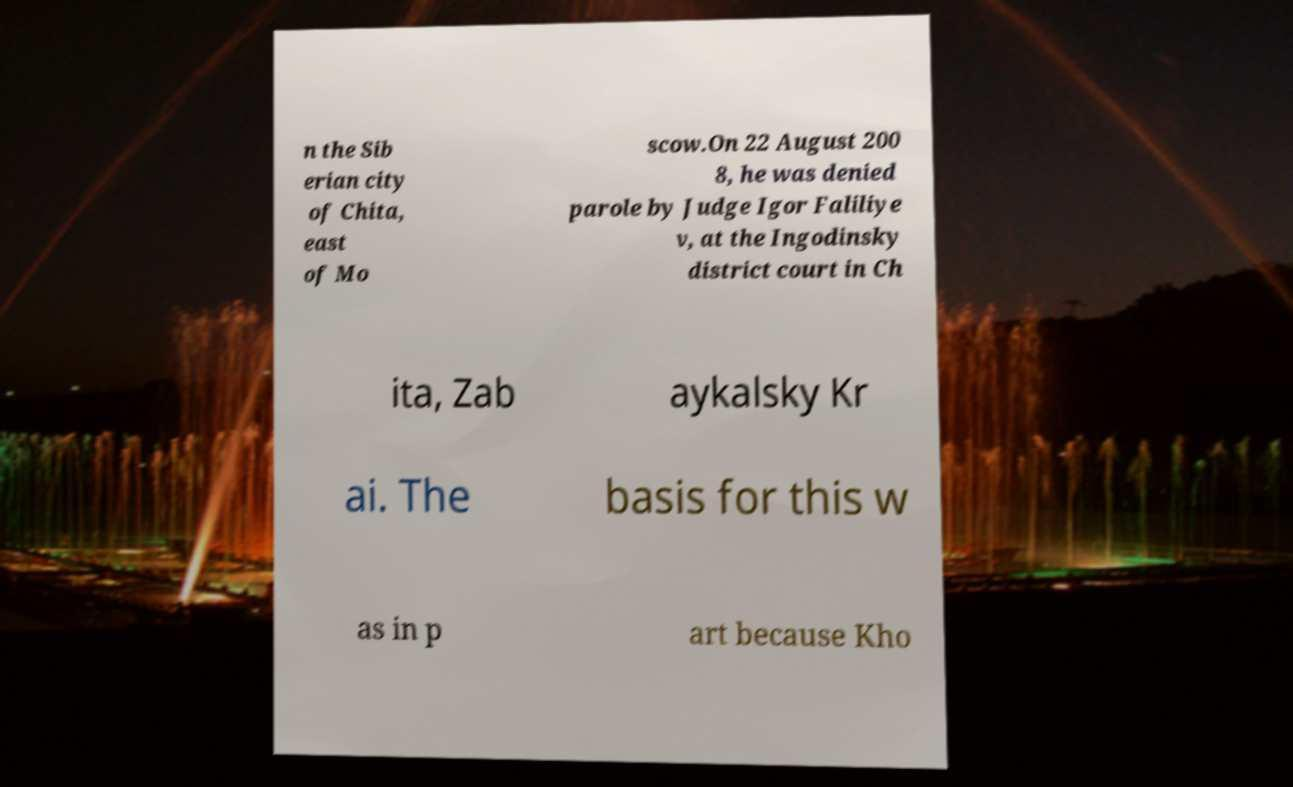What messages or text are displayed in this image? I need them in a readable, typed format. n the Sib erian city of Chita, east of Mo scow.On 22 August 200 8, he was denied parole by Judge Igor Faliliye v, at the Ingodinsky district court in Ch ita, Zab aykalsky Kr ai. The basis for this w as in p art because Kho 